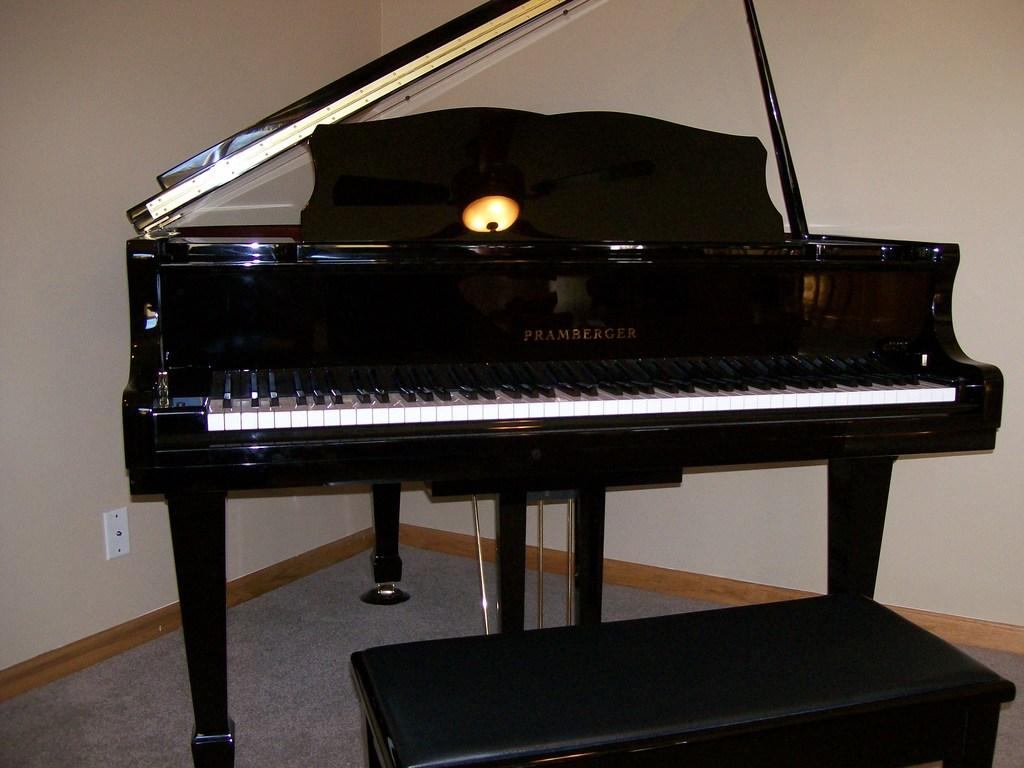What musical instrument is present in the image? There is a piano on the floor. What is located in front of the piano? There is a table in front of the piano. What is behind the piano in the image? There is a wall at the back of the piano. What type of coat is hanging on the wall behind the piano? There is no coat present in the image; only the piano, table, and wall are visible. 